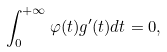<formula> <loc_0><loc_0><loc_500><loc_500>\int _ { 0 } ^ { + \infty } \varphi ( t ) g ^ { \prime } ( t ) d t = 0 ,</formula> 